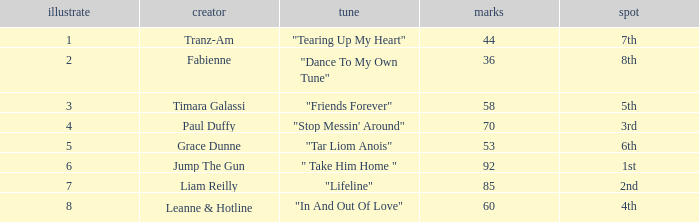Could you parse the entire table? {'header': ['illustrate', 'creator', 'tune', 'marks', 'spot'], 'rows': [['1', 'Tranz-Am', '"Tearing Up My Heart"', '44', '7th'], ['2', 'Fabienne', '"Dance To My Own Tune"', '36', '8th'], ['3', 'Timara Galassi', '"Friends Forever"', '58', '5th'], ['4', 'Paul Duffy', '"Stop Messin\' Around"', '70', '3rd'], ['5', 'Grace Dunne', '"Tar Liom Anois"', '53', '6th'], ['6', 'Jump The Gun', '" Take Him Home "', '92', '1st'], ['7', 'Liam Reilly', '"Lifeline"', '85', '2nd'], ['8', 'Leanne & Hotline', '"In And Out Of Love"', '60', '4th']]} What's the average draw for the song "stop messin' around"? 4.0. 